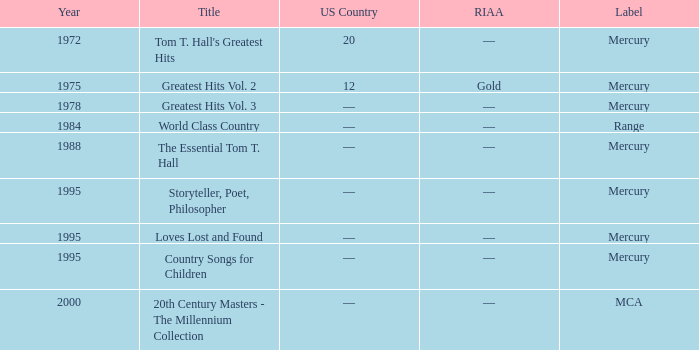Could you help me parse every detail presented in this table? {'header': ['Year', 'Title', 'US Country', 'RIAA', 'Label'], 'rows': [['1972', "Tom T. Hall's Greatest Hits", '20', '—', 'Mercury'], ['1975', 'Greatest Hits Vol. 2', '12', 'Gold', 'Mercury'], ['1978', 'Greatest Hits Vol. 3', '—', '—', 'Mercury'], ['1984', 'World Class Country', '—', '—', 'Range'], ['1988', 'The Essential Tom T. Hall', '—', '—', 'Mercury'], ['1995', 'Storyteller, Poet, Philosopher', '—', '—', 'Mercury'], ['1995', 'Loves Lost and Found', '—', '—', 'Mercury'], ['1995', 'Country Songs for Children', '—', '—', 'Mercury'], ['2000', '20th Century Masters - The Millennium Collection', '—', '—', 'MCA']]} What label had the album after 1978? Range, Mercury, Mercury, Mercury, Mercury, MCA. 